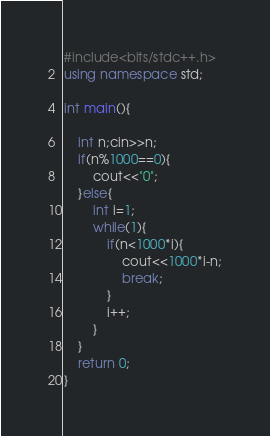Convert code to text. <code><loc_0><loc_0><loc_500><loc_500><_C++_>#include<bits/stdc++.h>
using namespace std;

int main(){
	
	int n;cin>>n;
	if(n%1000==0){
		cout<<"0";
	}else{
		int i=1;
		while(1){
			if(n<1000*i){
				cout<<1000*i-n;
				break;
			}
			i++;
		}
	}
	return 0;
}</code> 